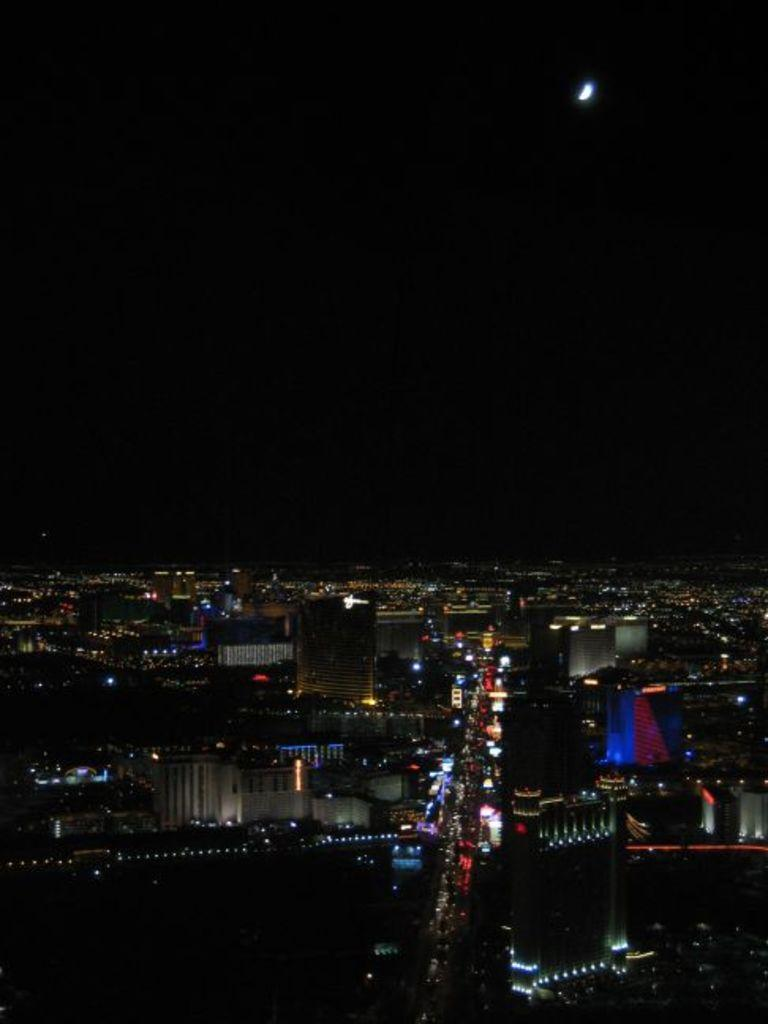What type of structures are present in the image? There are buildings in the image. What can be seen illuminating the scene in the image? There are lights visible in the image. What celestial body is visible in the background of the image? The moon is visible in the background of the image. What is the color of the sky in the image? The sky is black in color. Where is the pen located on the desk in the image? There is no desk or pen present in the image. 